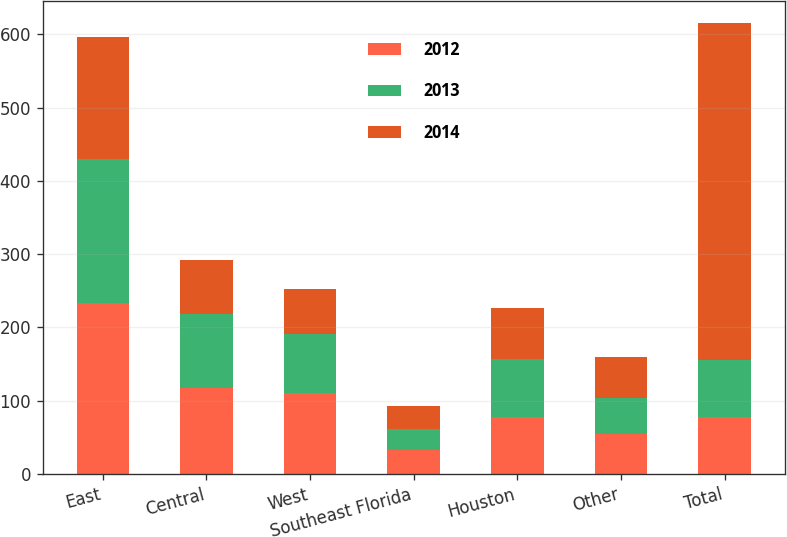Convert chart to OTSL. <chart><loc_0><loc_0><loc_500><loc_500><stacked_bar_chart><ecel><fcel>East<fcel>Central<fcel>West<fcel>Southeast Florida<fcel>Houston<fcel>Other<fcel>Total<nl><fcel>2012<fcel>233<fcel>117<fcel>111<fcel>32<fcel>78<fcel>54<fcel>78<nl><fcel>2013<fcel>197<fcel>101<fcel>80<fcel>30<fcel>79<fcel>50<fcel>78<nl><fcel>2014<fcel>167<fcel>74<fcel>61<fcel>31<fcel>70<fcel>56<fcel>459<nl></chart> 